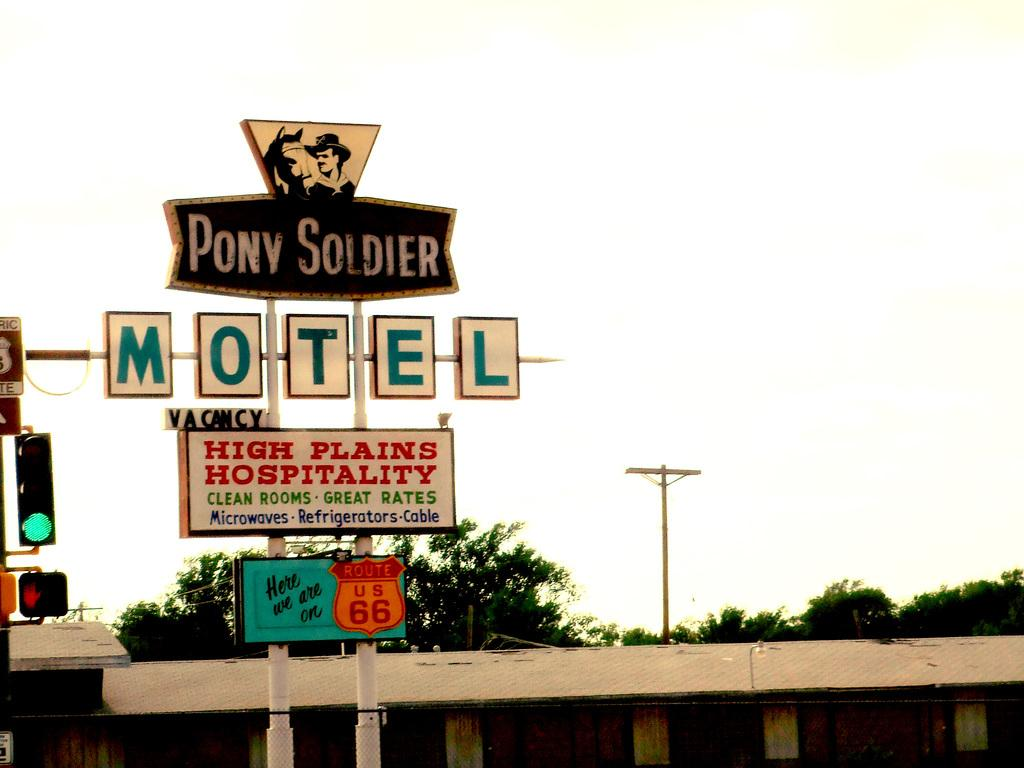Provide a one-sentence caption for the provided image. Street sign with one that says "Pony Soldier" for an establishment. 